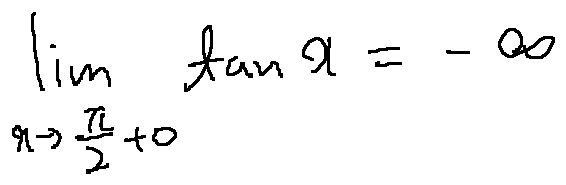Convert formula to latex. <formula><loc_0><loc_0><loc_500><loc_500>\lim \lim i t s _ { x \rightarrow \frac { \pi } { 2 } + 0 } \tan x = - \infty</formula> 